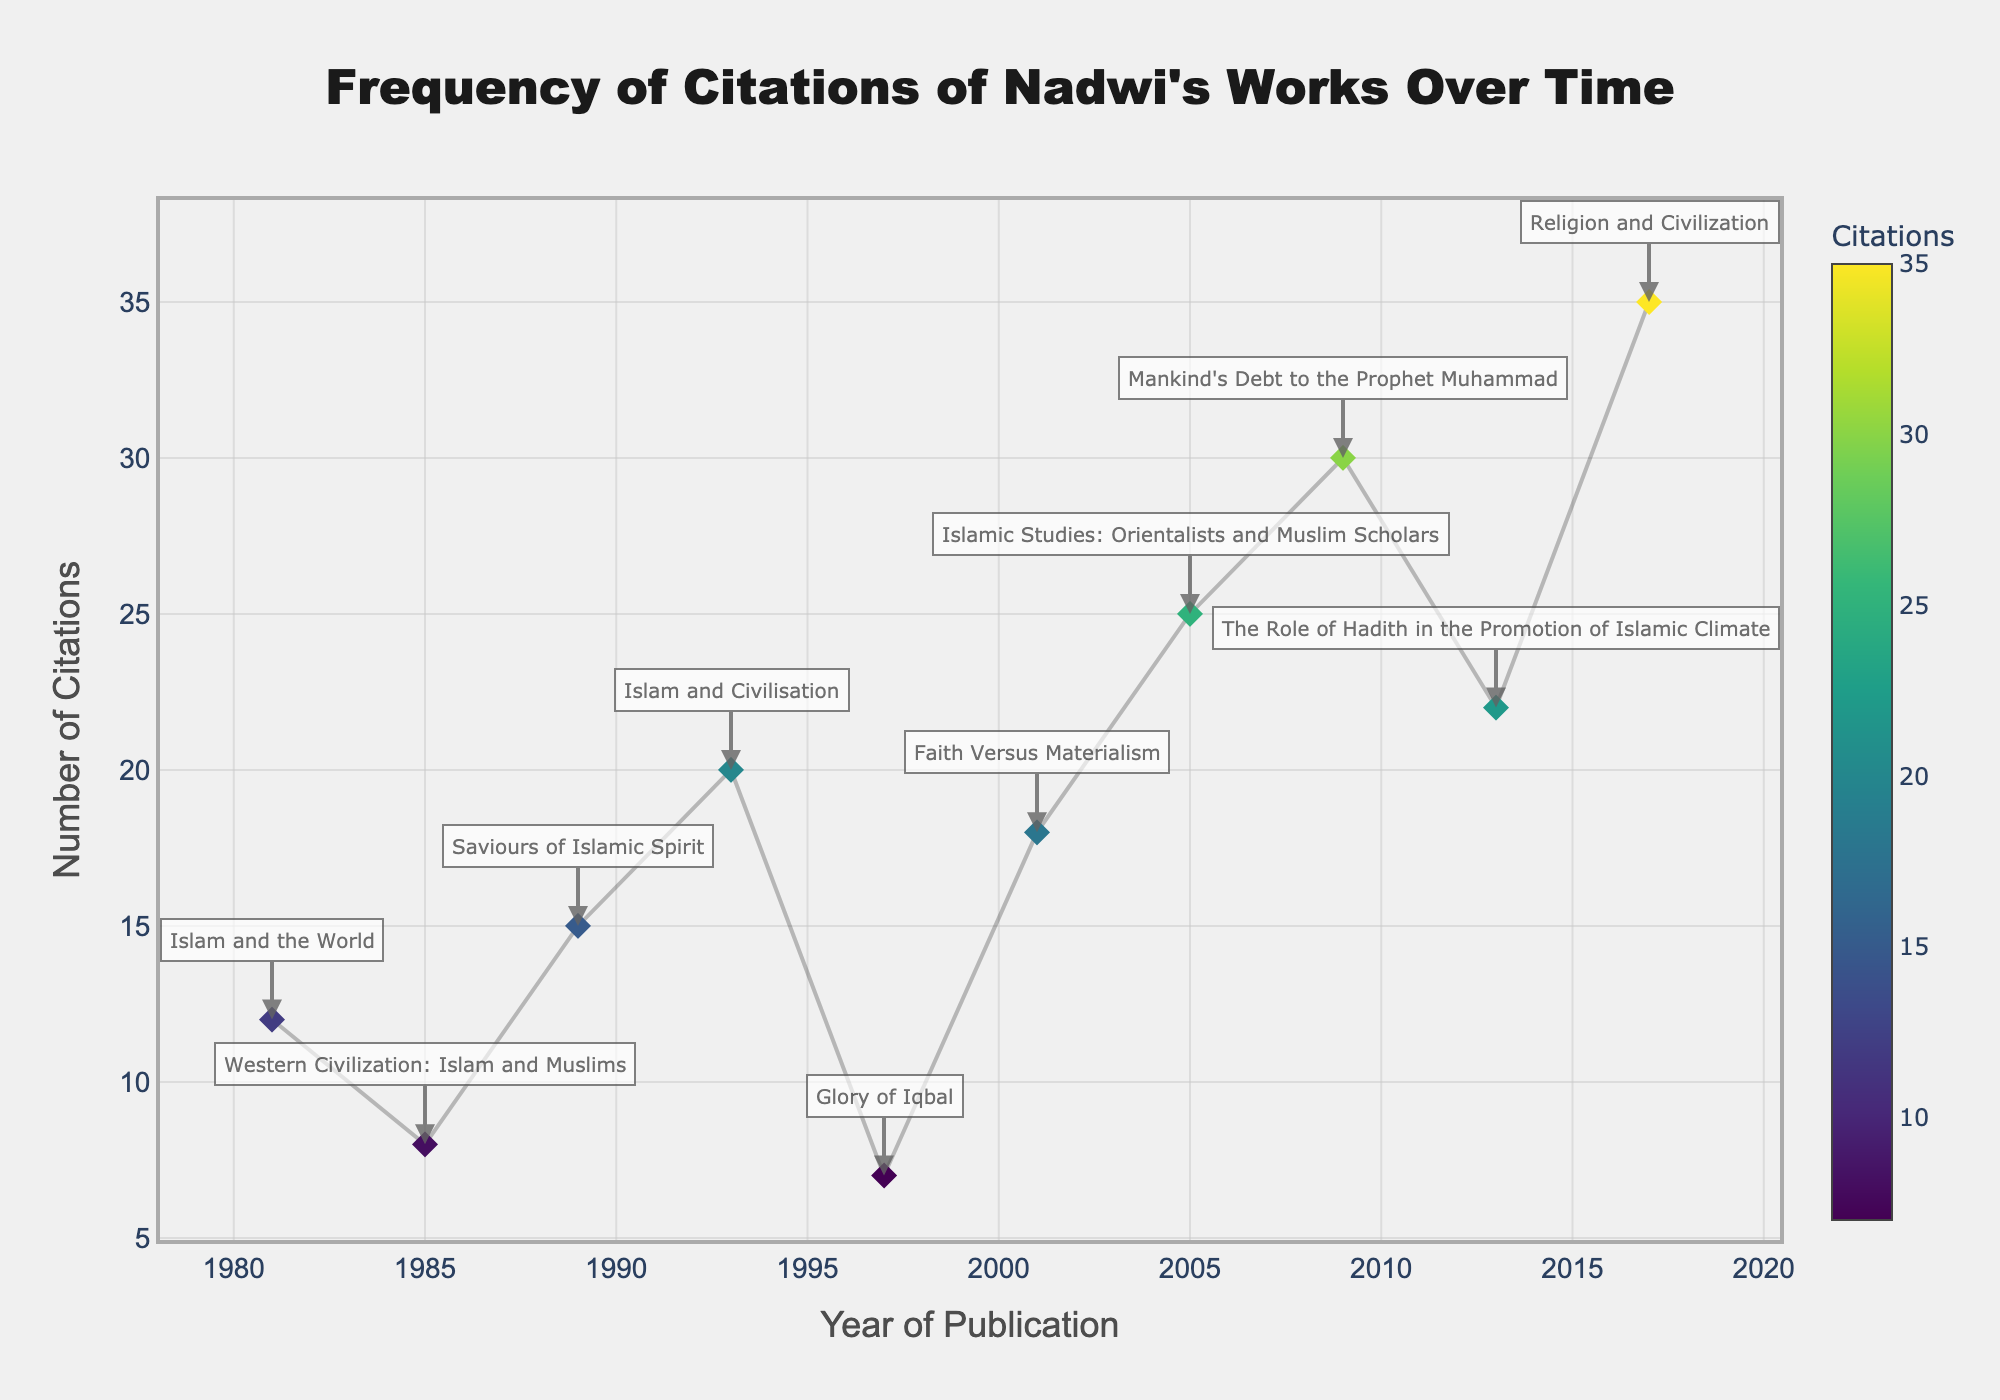How many total citations are shown across all years? Sum all the citations across the years (12+8+15+20+7+18+25+30+22+35) which equals 192.
Answer: 192 Which publication has the highest number of citations? Look for the highest value on the y-axis and identify the corresponding publication label. It is "Religion and Civilization" with 35 citations.
Answer: Religion and Civilization In which year did "Mankind's Debt to the Prophet Muhammad" get published, and how many citations does it have? Refer to the annotations to find the year and the corresponding number of citations. "Mankind's Debt to the Prophet Muhammad" was published in 2009 and has 30 citations.
Answer: 2009, 30 What's the average number of citations per publication? First, calculate the sum of all citations: 192. Divide this sum by the number of publications: 192 / 10 = 19.2
Answer: 19.2 Which publication has the lowest number of citations? What year was it published? Identify the publication and year with the lowest y-axis value. "Glory of Iqbal" is the publication with 7 citations, published in 1997.
Answer: Glory of Iqbal, 1997 What is the difference in citations between the works published in 1997 and 2017? Determine the citations for 1997's publication ("Glory of Iqbal") and 2017's publication ("Religion and Civilization"), then calculate the difference: 35 - 7 = 28.
Answer: 28 How many publications have 20 or more citations? Count the points that have a y-axis value of 20 or greater: "Islam and Civilisation," "Faith Versus Materialism," "Islamic Studies: Orientalists and Muslim Scholars," "Mankind's Debt to the Prophet Muhammad," "The Role of Hadith in the Promotion of Islamic Climate," and "Religion and Civilization," make a total of 6 publications.
Answer: 6 What does the title of the plot indicate? The title of the plot is "Frequency of Citations of Nadwi's Works Over Time," indicating the focus on the number of academic citations his works received over different years.
Answer: Frequency of Citations of Nadwi's Works Over Time 